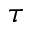<formula> <loc_0><loc_0><loc_500><loc_500>\tau</formula> 